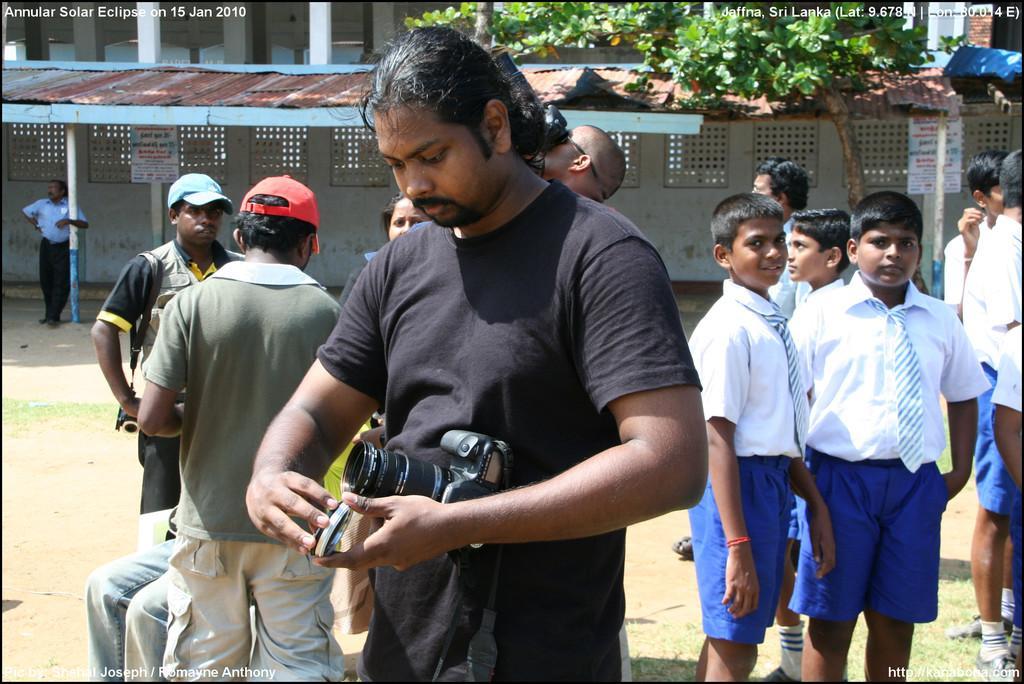How would you summarize this image in a sentence or two? In this image we can see a group of persons are standing on the ground, here a man is holding a camera in the hands, here is the grass, here is the tree, here is the pole, here is the wall. 